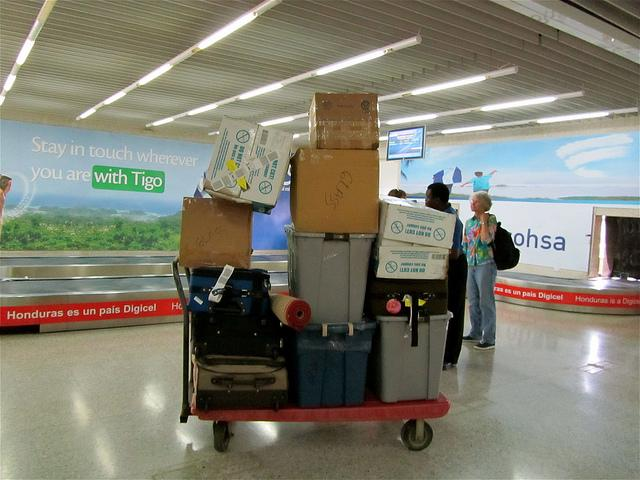What country is this venue situated in?

Choices:
A) spain
B) honduras
C) chile
D) mexico honduras 